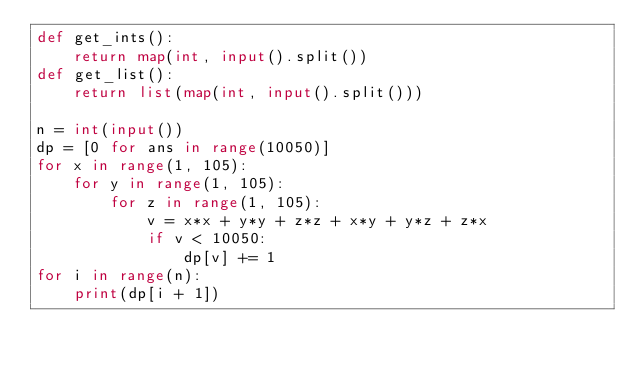<code> <loc_0><loc_0><loc_500><loc_500><_Python_>def get_ints():
	return map(int, input().split())
def get_list():
	return list(map(int, input().split()))

n = int(input())
dp = [0 for ans in range(10050)]
for x in range(1, 105):
	for y in range(1, 105):
		for z in range(1, 105):
			v = x*x + y*y + z*z + x*y + y*z + z*x
			if v < 10050:
				dp[v] += 1
for i in range(n):
	print(dp[i + 1])</code> 